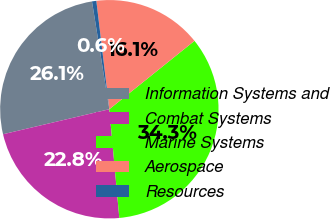Convert chart. <chart><loc_0><loc_0><loc_500><loc_500><pie_chart><fcel>Information Systems and<fcel>Combat Systems<fcel>Marine Systems<fcel>Aerospace<fcel>Resources<nl><fcel>26.14%<fcel>22.78%<fcel>34.31%<fcel>16.13%<fcel>0.64%<nl></chart> 